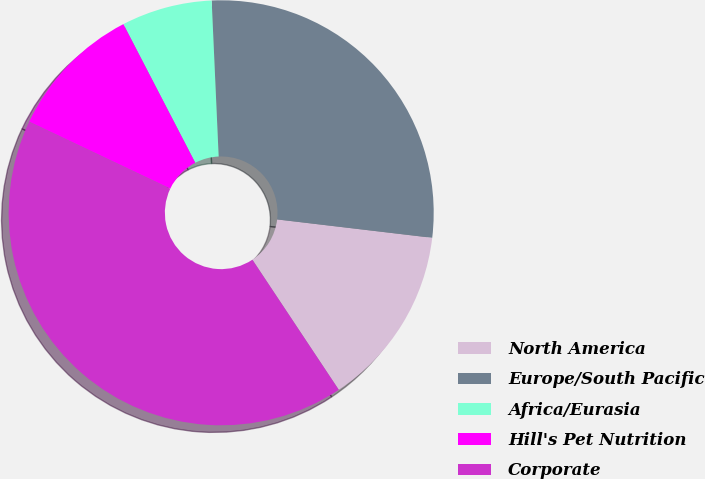<chart> <loc_0><loc_0><loc_500><loc_500><pie_chart><fcel>North America<fcel>Europe/South Pacific<fcel>Africa/Eurasia<fcel>Hill's Pet Nutrition<fcel>Corporate<nl><fcel>13.79%<fcel>27.59%<fcel>6.9%<fcel>10.34%<fcel>41.38%<nl></chart> 